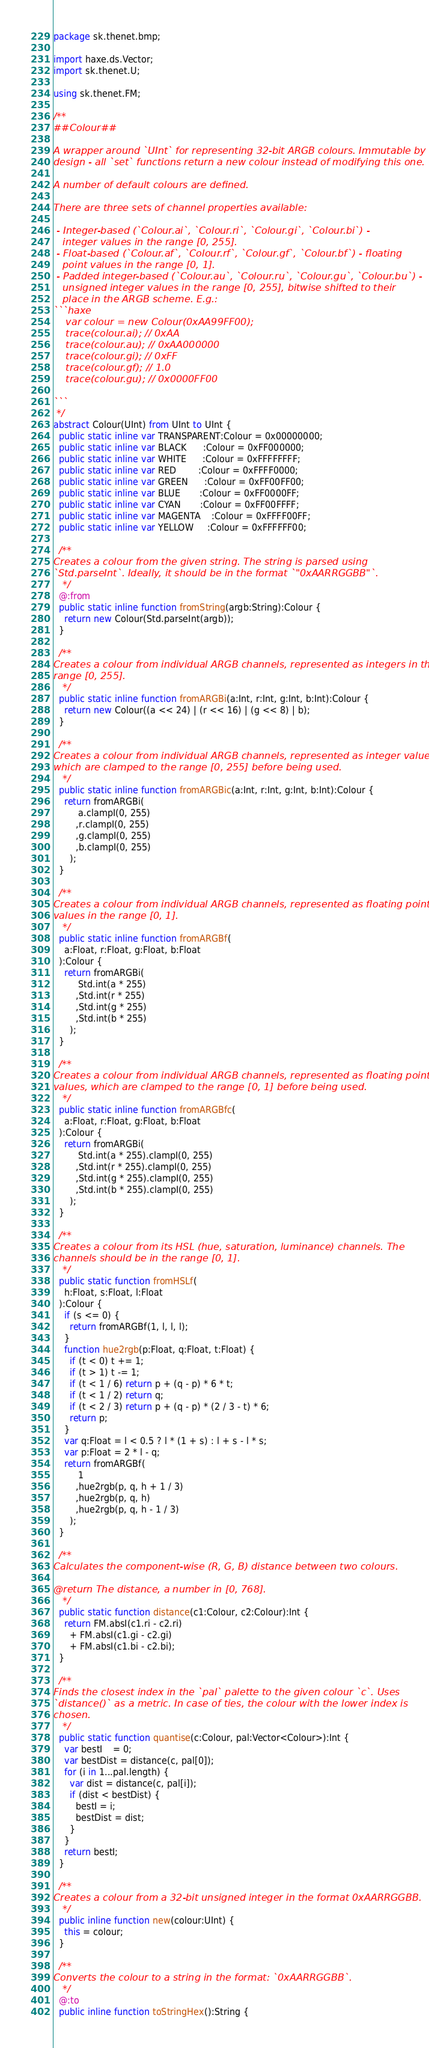Convert code to text. <code><loc_0><loc_0><loc_500><loc_500><_Haxe_>package sk.thenet.bmp;

import haxe.ds.Vector;
import sk.thenet.U;

using sk.thenet.FM;

/**
##Colour##

A wrapper around `UInt` for representing 32-bit ARGB colours. Immutable by
design - all `set` functions return a new colour instead of modifying this one.

A number of default colours are defined.

There are three sets of channel properties available:

 - Integer-based (`Colour.ai`, `Colour.ri`, `Colour.gi`, `Colour.bi`) -
   integer values in the range [0, 255].
 - Float-based (`Colour.af`, `Colour.rf`, `Colour.gf`, `Colour.bf`) - floating
   point values in the range [0, 1].
 - Padded integer-based (`Colour.au`, `Colour.ru`, `Colour.gu`, `Colour.bu`) -
   unsigned integer values in the range [0, 255], bitwise shifted to their
   place in the ARGB scheme. E.g.:
```haxe
    var colour = new Colour(0xAA99FF00);
    trace(colour.ai); // 0xAA
    trace(colour.au); // 0xAA000000
    trace(colour.gi); // 0xFF
    trace(colour.gf); // 1.0
    trace(colour.gu); // 0x0000FF00

```
 */
abstract Colour(UInt) from UInt to UInt {
  public static inline var TRANSPARENT:Colour = 0x00000000;
  public static inline var BLACK      :Colour = 0xFF000000;
  public static inline var WHITE      :Colour = 0xFFFFFFFF;
  public static inline var RED        :Colour = 0xFFFF0000;
  public static inline var GREEN      :Colour = 0xFF00FF00;
  public static inline var BLUE       :Colour = 0xFF0000FF;
  public static inline var CYAN       :Colour = 0xFF00FFFF;
  public static inline var MAGENTA    :Colour = 0xFFFF00FF;
  public static inline var YELLOW     :Colour = 0xFFFFFF00;
  
  /**
Creates a colour from the given string. The string is parsed using
`Std.parseInt`. Ideally, it should be in the format `"0xAARRGGBB"`.
   */
  @:from
  public static inline function fromString(argb:String):Colour {
    return new Colour(Std.parseInt(argb));
  }
  
  /**
Creates a colour from individual ARGB channels, represented as integers in the
range [0, 255].
   */
  public static inline function fromARGBi(a:Int, r:Int, g:Int, b:Int):Colour {
    return new Colour((a << 24) | (r << 16) | (g << 8) | b);
  }
  
  /**
Creates a colour from individual ARGB channels, represented as integer values,
which are clamped to the range [0, 255] before being used.
   */
  public static inline function fromARGBic(a:Int, r:Int, g:Int, b:Int):Colour {
    return fromARGBi(
         a.clampI(0, 255)
        ,r.clampI(0, 255)
        ,g.clampI(0, 255)
        ,b.clampI(0, 255)
      );
  }
  
  /**
Creates a colour from individual ARGB channels, represented as floating point
values in the range [0, 1].
   */
  public static inline function fromARGBf(
    a:Float, r:Float, g:Float, b:Float
  ):Colour {
    return fromARGBi(
         Std.int(a * 255)
        ,Std.int(r * 255)
        ,Std.int(g * 255)
        ,Std.int(b * 255)
      );
  }
  
  /**
Creates a colour from individual ARGB channels, represented as floating point
values, which are clamped to the range [0, 1] before being used.
   */
  public static inline function fromARGBfc(
    a:Float, r:Float, g:Float, b:Float
  ):Colour {
    return fromARGBi(
         Std.int(a * 255).clampI(0, 255)
        ,Std.int(r * 255).clampI(0, 255)
        ,Std.int(g * 255).clampI(0, 255)
        ,Std.int(b * 255).clampI(0, 255)
      );
  }
  
  /**
Creates a colour from its HSL (hue, saturation, luminance) channels. The
channels should be in the range [0, 1].
   */
  public static function fromHSLf(
    h:Float, s:Float, l:Float
  ):Colour {
    if (s <= 0) {
      return fromARGBf(1, l, l, l);
    }
    function hue2rgb(p:Float, q:Float, t:Float) {
      if (t < 0) t += 1;
      if (t > 1) t -= 1;
      if (t < 1 / 6) return p + (q - p) * 6 * t;
      if (t < 1 / 2) return q;
      if (t < 2 / 3) return p + (q - p) * (2 / 3 - t) * 6;
      return p;
    }
    var q:Float = l < 0.5 ? l * (1 + s) : l + s - l * s;
    var p:Float = 2 * l - q;
    return fromARGBf(
         1
        ,hue2rgb(p, q, h + 1 / 3)
        ,hue2rgb(p, q, h)
        ,hue2rgb(p, q, h - 1 / 3)
      );
  }
  
  /**
Calculates the component-wise (R, G, B) distance between two colours.

@return The distance, a number in [0, 768].
   */
  public static function distance(c1:Colour, c2:Colour):Int {
    return FM.absI(c1.ri - c2.ri)
      + FM.absI(c1.gi - c2.gi)
      + FM.absI(c1.bi - c2.bi);
  }
  
  /**
Finds the closest index in the `pal` palette to the given colour `c`. Uses
`distance()` as a metric. In case of ties, the colour with the lower index is
chosen.
   */
  public static function quantise(c:Colour, pal:Vector<Colour>):Int {
    var bestI    = 0;
    var bestDist = distance(c, pal[0]);
    for (i in 1...pal.length) {
      var dist = distance(c, pal[i]);
      if (dist < bestDist) {
        bestI = i;
        bestDist = dist;
      }
    }
    return bestI;
  }
  
  /**
Creates a colour from a 32-bit unsigned integer in the format 0xAARRGGBB.
   */
  public inline function new(colour:UInt) {
    this = colour;
  }
  
  /**
Converts the colour to a string in the format: `0xAARRGGBB`.
   */
  @:to
  public inline function toStringHex():String {</code> 